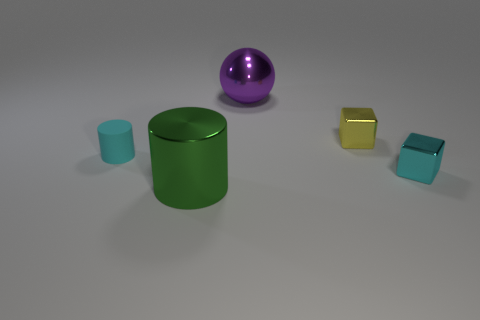There is a thing that is on the right side of the metal block that is behind the cyan matte cylinder; how many metal things are behind it?
Your answer should be very brief. 2. Is the number of big metal spheres on the right side of the small cyan shiny cube less than the number of purple balls left of the matte cylinder?
Provide a short and direct response. No. There is another object that is the same shape as the yellow object; what is its color?
Provide a succinct answer. Cyan. What is the size of the green cylinder?
Give a very brief answer. Large. What number of shiny spheres are the same size as the purple metallic thing?
Keep it short and to the point. 0. Is the tiny rubber cylinder the same color as the sphere?
Offer a very short reply. No. Is the material of the small cyan object left of the cyan metal block the same as the tiny block that is in front of the cyan rubber cylinder?
Ensure brevity in your answer.  No. Are there more cyan matte cylinders than small yellow cylinders?
Keep it short and to the point. Yes. Are there any other things of the same color as the matte object?
Give a very brief answer. Yes. Is the tiny cylinder made of the same material as the yellow thing?
Ensure brevity in your answer.  No. 